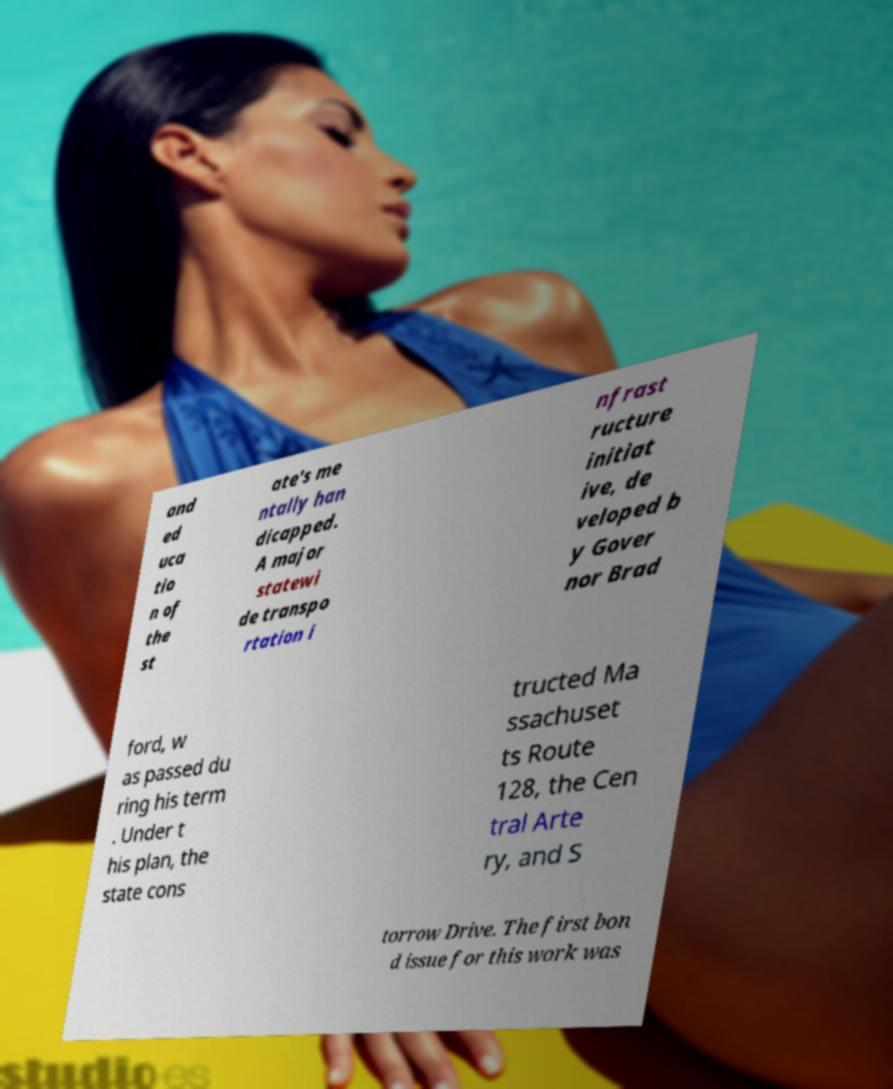There's text embedded in this image that I need extracted. Can you transcribe it verbatim? and ed uca tio n of the st ate's me ntally han dicapped. A major statewi de transpo rtation i nfrast ructure initiat ive, de veloped b y Gover nor Brad ford, w as passed du ring his term . Under t his plan, the state cons tructed Ma ssachuset ts Route 128, the Cen tral Arte ry, and S torrow Drive. The first bon d issue for this work was 